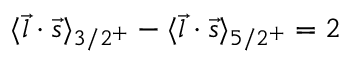Convert formula to latex. <formula><loc_0><loc_0><loc_500><loc_500>\langle \vec { l } \cdot \vec { s } \rangle _ { 3 / 2 ^ { + } } - \langle \vec { l } \cdot \vec { s } \rangle _ { 5 / 2 ^ { + } } = 2</formula> 